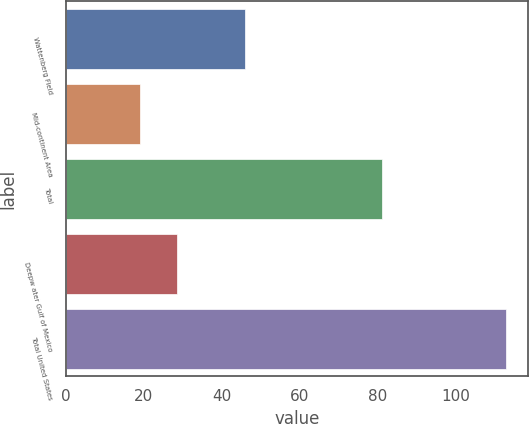Convert chart. <chart><loc_0><loc_0><loc_500><loc_500><bar_chart><fcel>Wattenberg Field<fcel>Mid-continent Area<fcel>Total<fcel>Deepw ater Gulf of Mexico<fcel>Total United States<nl><fcel>46<fcel>19<fcel>81<fcel>28.4<fcel>113<nl></chart> 